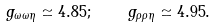Convert formula to latex. <formula><loc_0><loc_0><loc_500><loc_500>g _ { \omega \omega \eta } \simeq 4 . 8 5 ; \quad g _ { \rho \rho \eta } \simeq 4 . 9 5 .</formula> 